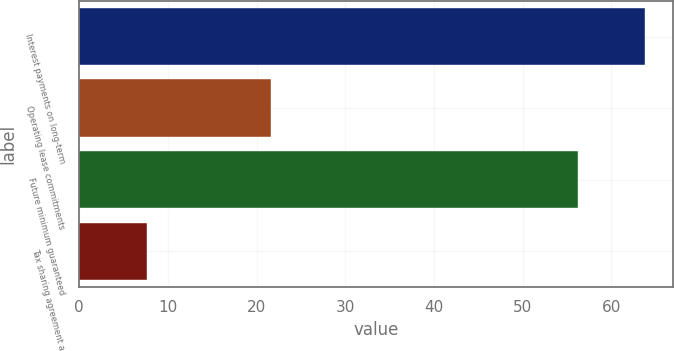Convert chart to OTSL. <chart><loc_0><loc_0><loc_500><loc_500><bar_chart><fcel>Interest payments on long-term<fcel>Operating lease commitments<fcel>Future minimum guaranteed<fcel>Tax sharing agreement a<nl><fcel>63.8<fcel>21.6<fcel>56.2<fcel>7.6<nl></chart> 